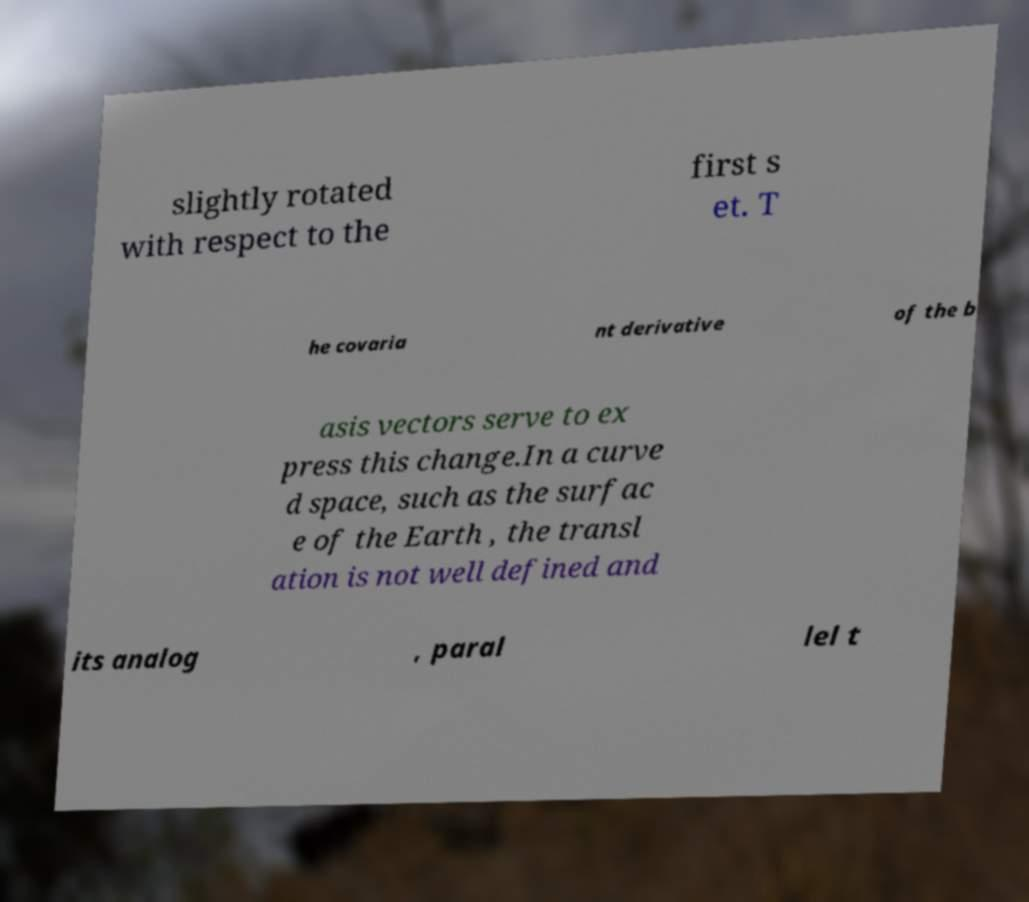Please read and relay the text visible in this image. What does it say? slightly rotated with respect to the first s et. T he covaria nt derivative of the b asis vectors serve to ex press this change.In a curve d space, such as the surfac e of the Earth , the transl ation is not well defined and its analog , paral lel t 